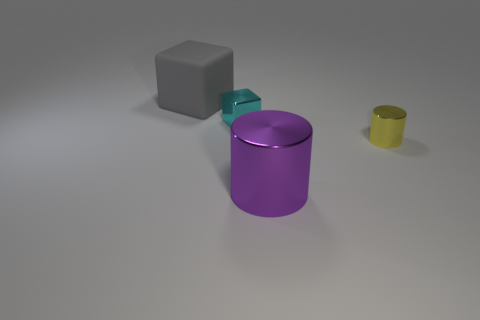Add 3 large red balls. How many objects exist? 7 Add 2 red things. How many red things exist? 2 Subtract 0 cyan balls. How many objects are left? 4 Subtract all red cubes. Subtract all cyan cylinders. How many cubes are left? 2 Subtract all big yellow metal blocks. Subtract all large purple shiny things. How many objects are left? 3 Add 1 big metallic things. How many big metallic things are left? 2 